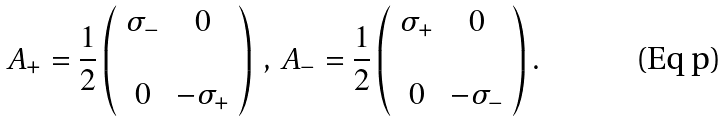<formula> <loc_0><loc_0><loc_500><loc_500>A _ { + } = \frac { 1 } { 2 } \left ( \begin{array} { c c } \sigma _ { - } & 0 \\ \\ 0 & - \sigma _ { + } \end{array} \right ) \, , \, A _ { - } = \frac { 1 } { 2 } \left ( \begin{array} { c c } \sigma _ { + } & 0 \\ \\ 0 & - \sigma _ { - } \end{array} \right ) .</formula> 